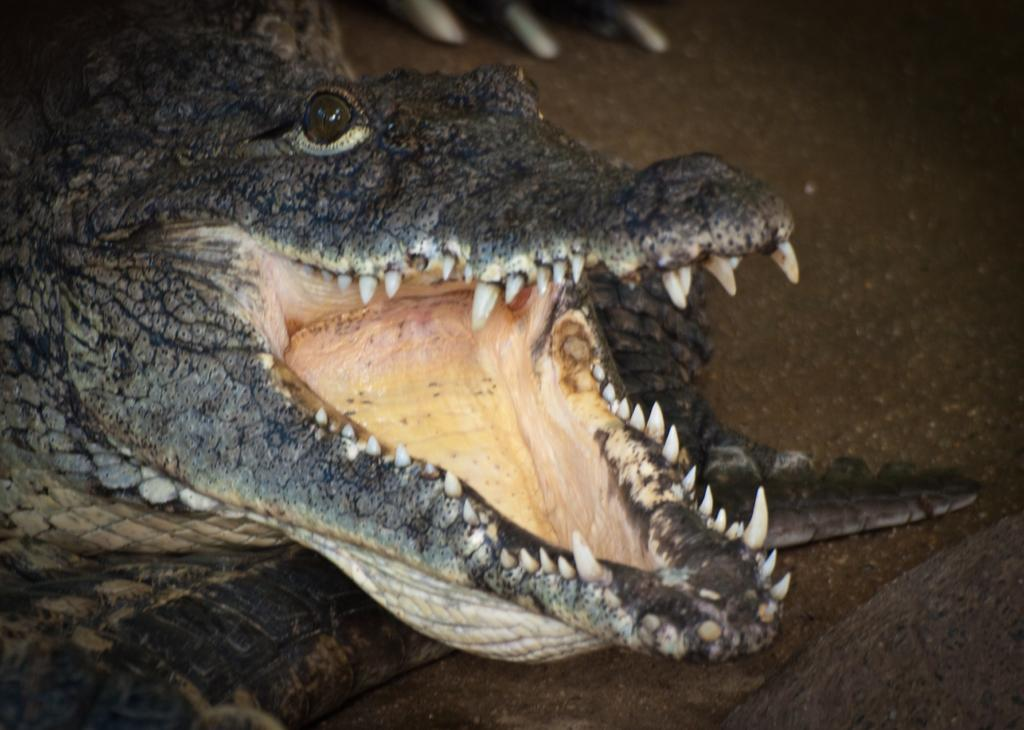What animal is present in the image? There is a crocodile in the image. Where is the crocodile located? The crocodile is on the ground. Can you describe the objects at the top of the image? Unfortunately, the objects at the top of the image are not clear enough to describe. What type of trousers is the laborer wearing in the image? There is no laborer or trousers present in the image; it features a crocodile on the ground. What is the cause of the loss experienced by the person in the image? There is no person or loss depicted in the image; it only shows a crocodile on the ground. 